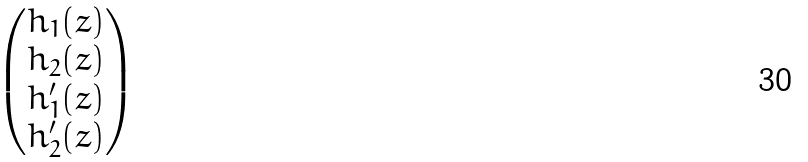<formula> <loc_0><loc_0><loc_500><loc_500>\begin{pmatrix} h _ { 1 } ( z ) \\ h _ { 2 } ( z ) \\ h _ { 1 } ^ { \prime } ( z ) \\ h _ { 2 } ^ { \prime } ( z ) \end{pmatrix}</formula> 